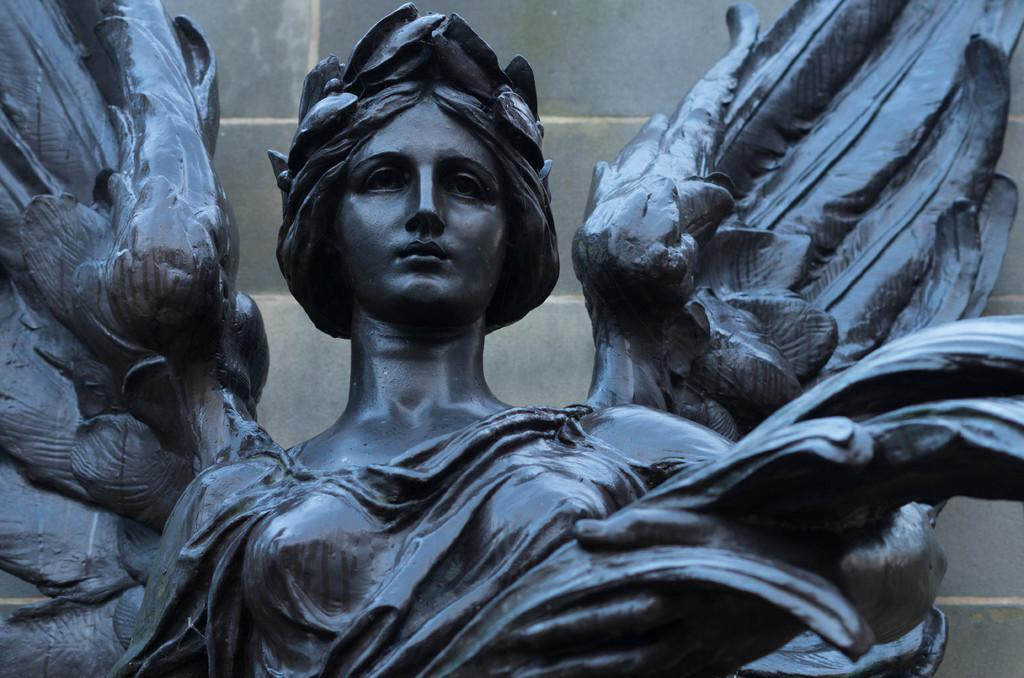What is the main subject of the image? There is a statue of a woman in the image. What can you tell about the statue's appearance? The statue is black in color. What is visible in the background of the image? There is a wall in the background of the image. How many clocks are hanging on the wall behind the statue in the image? There is no mention of clocks in the image, so we cannot determine their presence or quantity. 